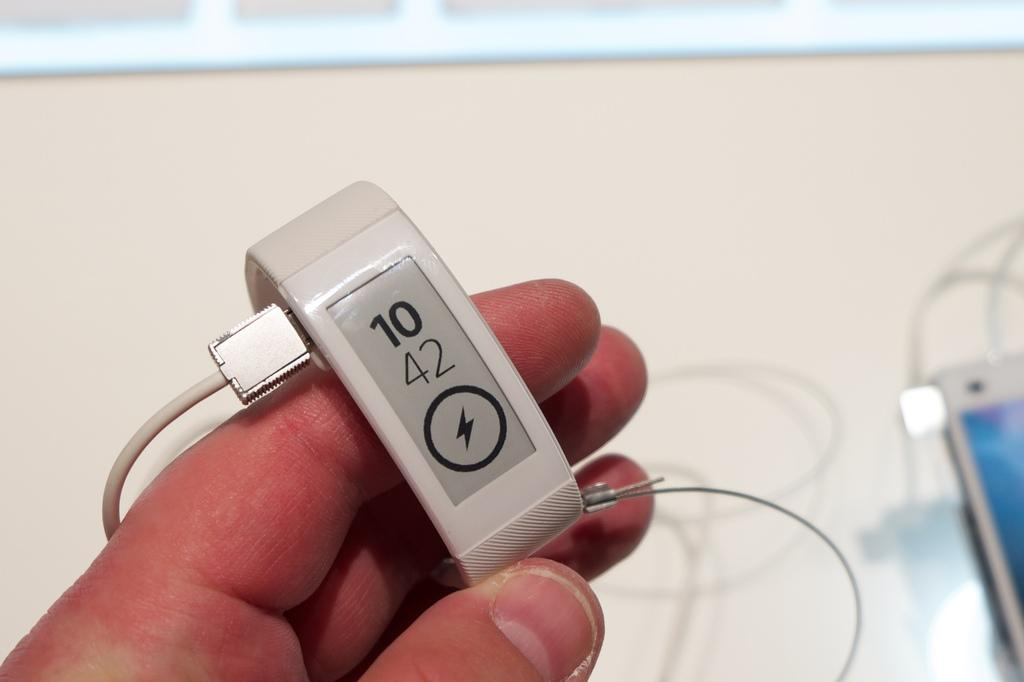<image>
Present a compact description of the photo's key features. A person is holding a fitbit that is charging, it reads 10 42. 